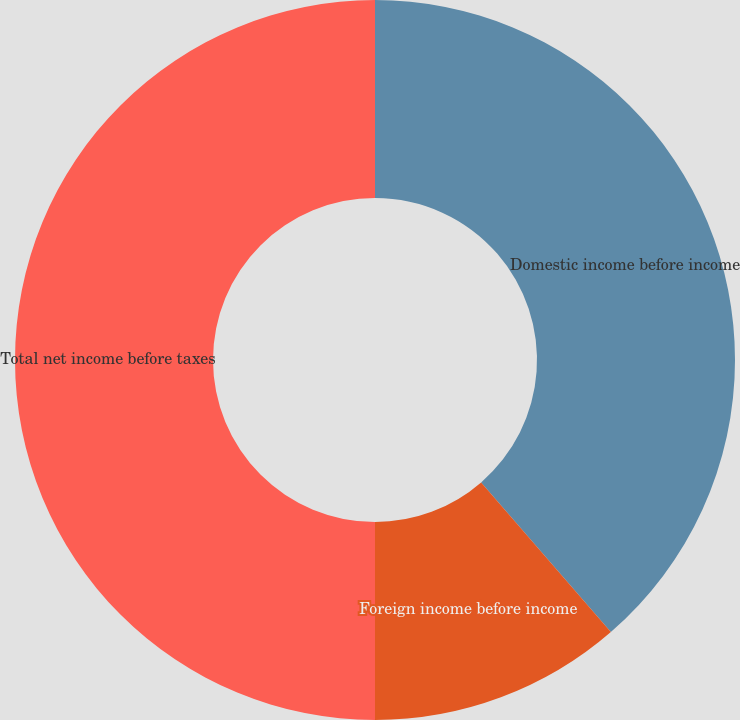<chart> <loc_0><loc_0><loc_500><loc_500><pie_chart><fcel>Domestic income before income<fcel>Foreign income before income<fcel>Total net income before taxes<nl><fcel>38.63%<fcel>11.37%<fcel>50.0%<nl></chart> 